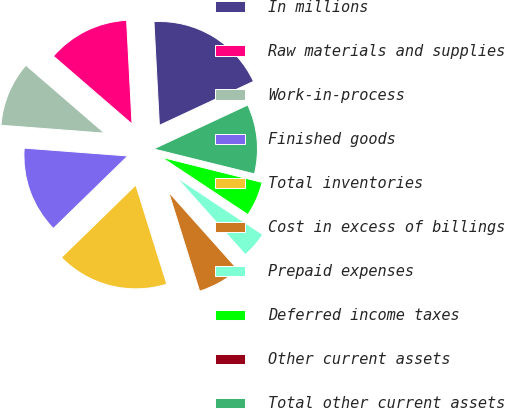Convert chart to OTSL. <chart><loc_0><loc_0><loc_500><loc_500><pie_chart><fcel>In millions<fcel>Raw materials and supplies<fcel>Work-in-process<fcel>Finished goods<fcel>Total inventories<fcel>Cost in excess of billings<fcel>Prepaid expenses<fcel>Deferred income taxes<fcel>Other current assets<fcel>Total other current assets<nl><fcel>18.88%<fcel>12.83%<fcel>10.13%<fcel>13.5%<fcel>17.53%<fcel>6.77%<fcel>4.08%<fcel>5.43%<fcel>0.04%<fcel>10.81%<nl></chart> 